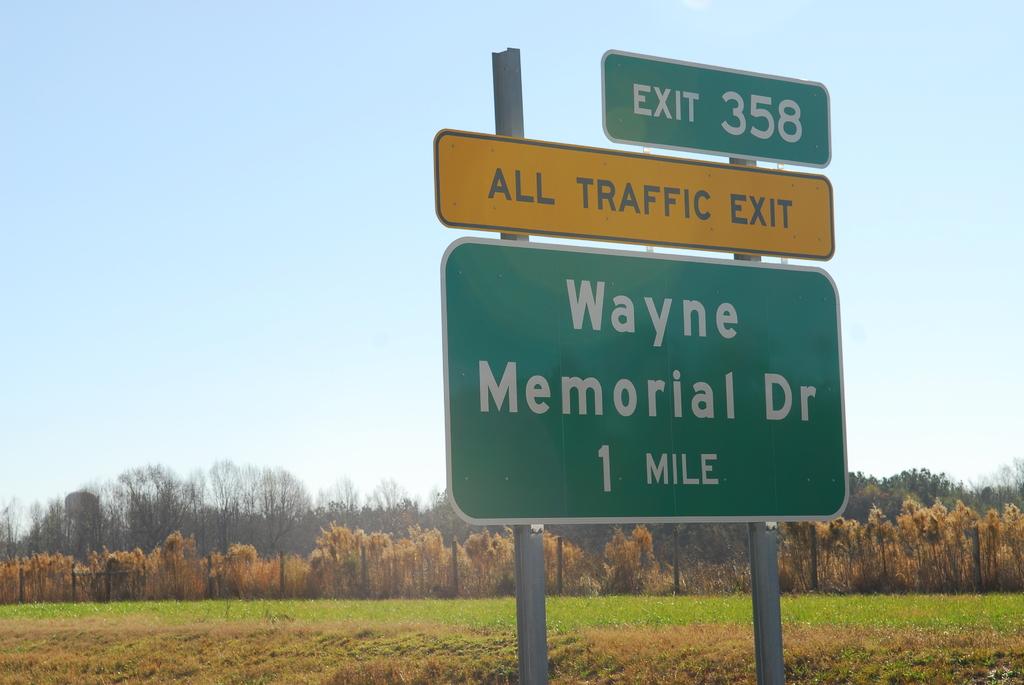What is the distance to wayne memorial dr?
Offer a very short reply. 1 mile. What must all traffic do?
Ensure brevity in your answer.  Exit. 